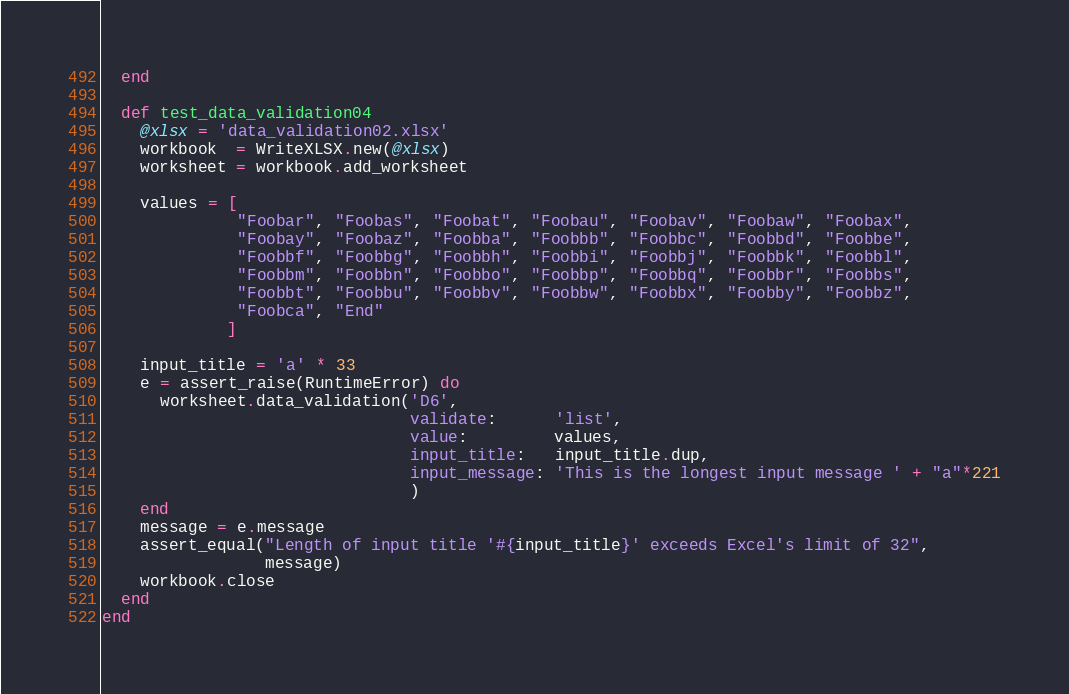Convert code to text. <code><loc_0><loc_0><loc_500><loc_500><_Ruby_>  end

  def test_data_validation04
    @xlsx = 'data_validation02.xlsx'
    workbook  = WriteXLSX.new(@xlsx)
    worksheet = workbook.add_worksheet

    values = [
              "Foobar", "Foobas", "Foobat", "Foobau", "Foobav", "Foobaw", "Foobax",
              "Foobay", "Foobaz", "Foobba", "Foobbb", "Foobbc", "Foobbd", "Foobbe",
              "Foobbf", "Foobbg", "Foobbh", "Foobbi", "Foobbj", "Foobbk", "Foobbl",
              "Foobbm", "Foobbn", "Foobbo", "Foobbp", "Foobbq", "Foobbr", "Foobbs",
              "Foobbt", "Foobbu", "Foobbv", "Foobbw", "Foobbx", "Foobby", "Foobbz",
              "Foobca", "End"
             ]

    input_title = 'a' * 33
    e = assert_raise(RuntimeError) do
      worksheet.data_validation('D6',
                                validate:      'list',
                                value:         values,
                                input_title:   input_title.dup,
                                input_message: 'This is the longest input message ' + "a"*221
                                )
    end
    message = e.message
    assert_equal("Length of input title '#{input_title}' exceeds Excel's limit of 32",
                 message)
    workbook.close
  end
end
</code> 